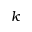Convert formula to latex. <formula><loc_0><loc_0><loc_500><loc_500>k</formula> 